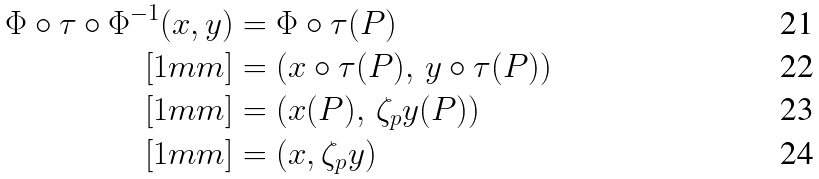Convert formula to latex. <formula><loc_0><loc_0><loc_500><loc_500>\Phi \circ \tau \circ \Phi ^ { - 1 } ( x , y ) & = \Phi \circ \tau ( P ) \\ [ 1 m m ] & = \left ( x \circ \tau ( P ) , \, y \circ \tau ( P ) \right ) \\ [ 1 m m ] & = \left ( x ( P ) , \, \zeta _ { p } y ( P ) \right ) \\ [ 1 m m ] & = ( x , \zeta _ { p } y )</formula> 